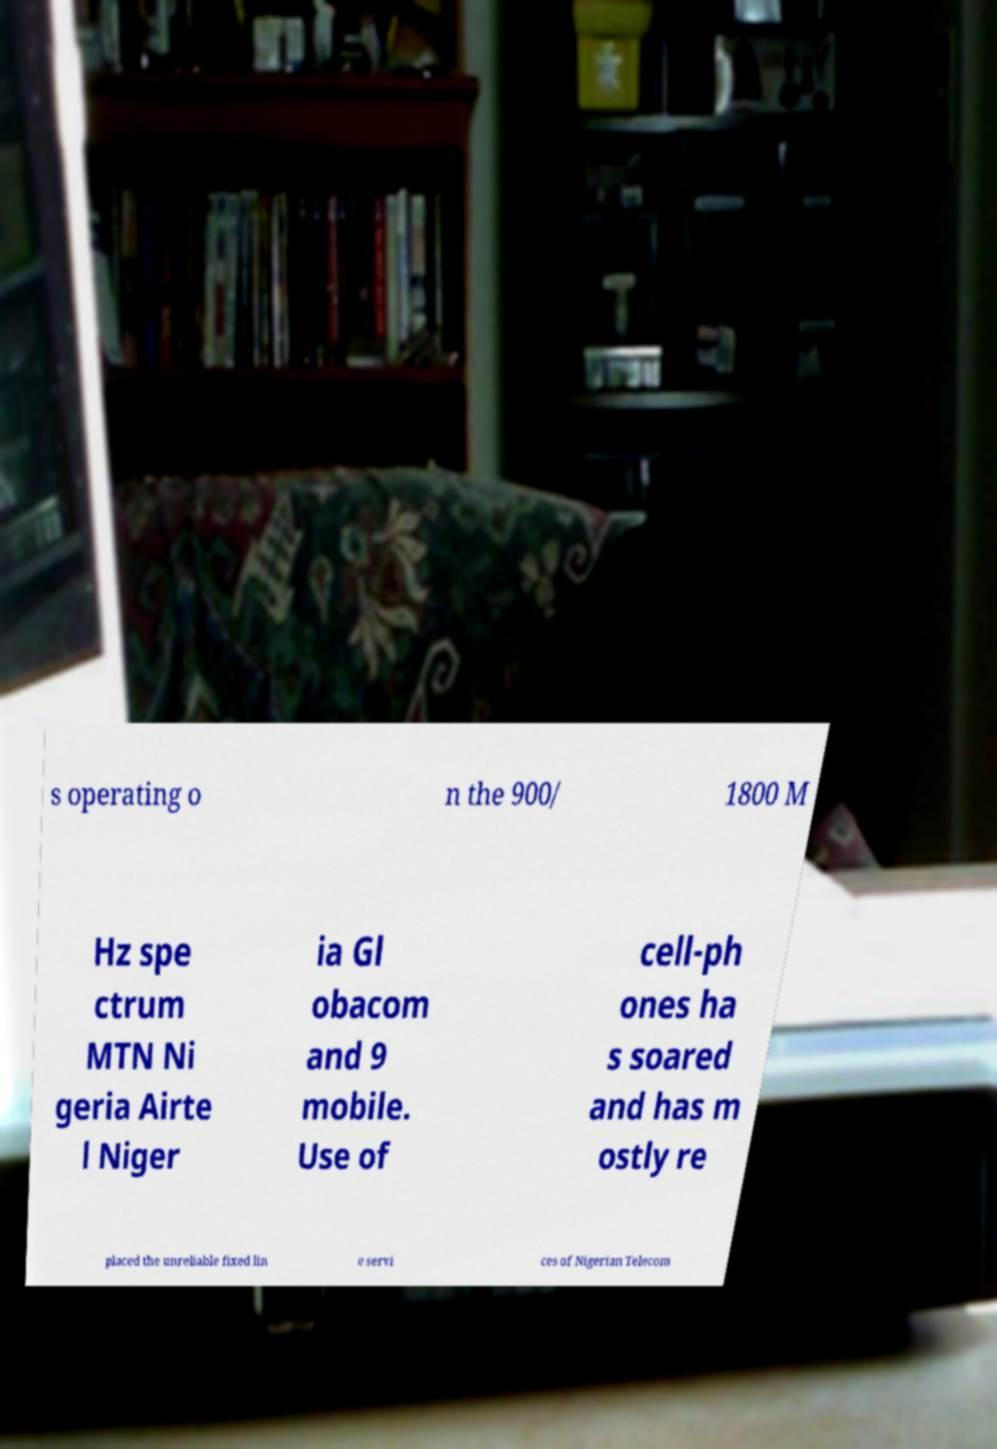Please identify and transcribe the text found in this image. s operating o n the 900/ 1800 M Hz spe ctrum MTN Ni geria Airte l Niger ia Gl obacom and 9 mobile. Use of cell-ph ones ha s soared and has m ostly re placed the unreliable fixed lin e servi ces of Nigerian Telecom 